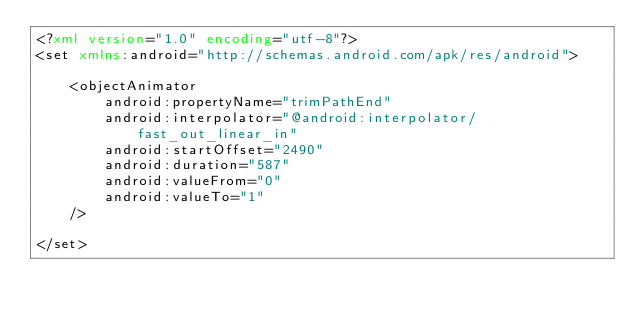Convert code to text. <code><loc_0><loc_0><loc_500><loc_500><_XML_><?xml version="1.0" encoding="utf-8"?>
<set xmlns:android="http://schemas.android.com/apk/res/android">

    <objectAnimator
        android:propertyName="trimPathEnd"
        android:interpolator="@android:interpolator/fast_out_linear_in"
        android:startOffset="2490"
        android:duration="587"
        android:valueFrom="0"
        android:valueTo="1"
    />

</set></code> 